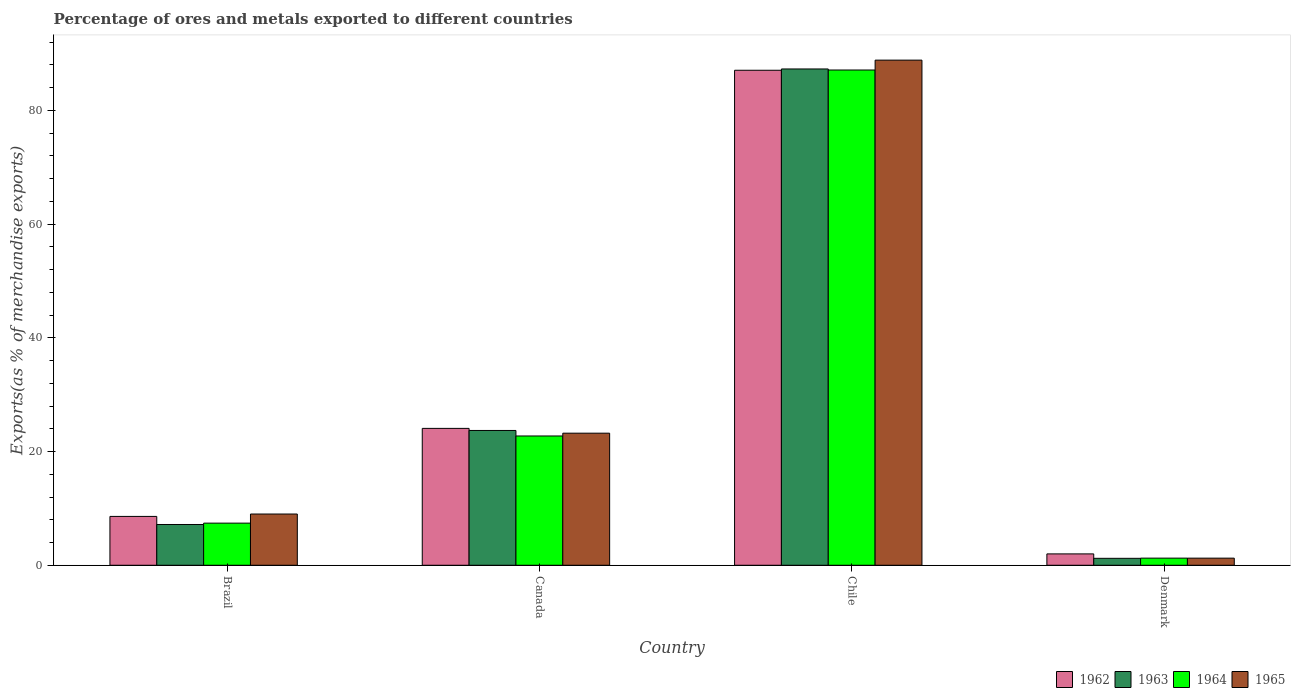Are the number of bars per tick equal to the number of legend labels?
Your answer should be very brief. Yes. Are the number of bars on each tick of the X-axis equal?
Provide a short and direct response. Yes. How many bars are there on the 2nd tick from the left?
Offer a very short reply. 4. What is the percentage of exports to different countries in 1962 in Denmark?
Your answer should be compact. 2. Across all countries, what is the maximum percentage of exports to different countries in 1963?
Your response must be concise. 87.28. Across all countries, what is the minimum percentage of exports to different countries in 1963?
Make the answer very short. 1.22. In which country was the percentage of exports to different countries in 1962 maximum?
Give a very brief answer. Chile. In which country was the percentage of exports to different countries in 1963 minimum?
Offer a terse response. Denmark. What is the total percentage of exports to different countries in 1963 in the graph?
Your answer should be compact. 119.38. What is the difference between the percentage of exports to different countries in 1965 in Canada and that in Chile?
Provide a short and direct response. -65.61. What is the difference between the percentage of exports to different countries in 1962 in Chile and the percentage of exports to different countries in 1964 in Canada?
Your answer should be very brief. 64.32. What is the average percentage of exports to different countries in 1965 per country?
Your answer should be compact. 30.58. What is the difference between the percentage of exports to different countries of/in 1963 and percentage of exports to different countries of/in 1965 in Denmark?
Offer a terse response. -0.03. In how many countries, is the percentage of exports to different countries in 1963 greater than 56 %?
Offer a very short reply. 1. What is the ratio of the percentage of exports to different countries in 1965 in Brazil to that in Canada?
Offer a very short reply. 0.39. Is the difference between the percentage of exports to different countries in 1963 in Canada and Chile greater than the difference between the percentage of exports to different countries in 1965 in Canada and Chile?
Provide a short and direct response. Yes. What is the difference between the highest and the second highest percentage of exports to different countries in 1963?
Offer a terse response. -16.54. What is the difference between the highest and the lowest percentage of exports to different countries in 1963?
Give a very brief answer. 86.06. In how many countries, is the percentage of exports to different countries in 1965 greater than the average percentage of exports to different countries in 1965 taken over all countries?
Your answer should be very brief. 1. Is it the case that in every country, the sum of the percentage of exports to different countries in 1963 and percentage of exports to different countries in 1964 is greater than the sum of percentage of exports to different countries in 1962 and percentage of exports to different countries in 1965?
Make the answer very short. No. What does the 1st bar from the right in Canada represents?
Keep it short and to the point. 1965. Is it the case that in every country, the sum of the percentage of exports to different countries in 1964 and percentage of exports to different countries in 1962 is greater than the percentage of exports to different countries in 1965?
Provide a short and direct response. Yes. Are all the bars in the graph horizontal?
Offer a terse response. No. How many countries are there in the graph?
Make the answer very short. 4. Are the values on the major ticks of Y-axis written in scientific E-notation?
Provide a short and direct response. No. Does the graph contain any zero values?
Ensure brevity in your answer.  No. Where does the legend appear in the graph?
Your answer should be very brief. Bottom right. What is the title of the graph?
Your answer should be very brief. Percentage of ores and metals exported to different countries. Does "1960" appear as one of the legend labels in the graph?
Your response must be concise. No. What is the label or title of the X-axis?
Your answer should be very brief. Country. What is the label or title of the Y-axis?
Provide a short and direct response. Exports(as % of merchandise exports). What is the Exports(as % of merchandise exports) in 1962 in Brazil?
Provide a succinct answer. 8.59. What is the Exports(as % of merchandise exports) of 1963 in Brazil?
Provide a succinct answer. 7.17. What is the Exports(as % of merchandise exports) of 1964 in Brazil?
Ensure brevity in your answer.  7.41. What is the Exports(as % of merchandise exports) of 1965 in Brazil?
Offer a very short reply. 9.01. What is the Exports(as % of merchandise exports) of 1962 in Canada?
Ensure brevity in your answer.  24.07. What is the Exports(as % of merchandise exports) in 1963 in Canada?
Provide a succinct answer. 23.71. What is the Exports(as % of merchandise exports) of 1964 in Canada?
Offer a very short reply. 22.74. What is the Exports(as % of merchandise exports) of 1965 in Canada?
Your answer should be compact. 23.23. What is the Exports(as % of merchandise exports) in 1962 in Chile?
Provide a short and direct response. 87.06. What is the Exports(as % of merchandise exports) in 1963 in Chile?
Provide a short and direct response. 87.28. What is the Exports(as % of merchandise exports) in 1964 in Chile?
Provide a short and direct response. 87.1. What is the Exports(as % of merchandise exports) of 1965 in Chile?
Provide a succinct answer. 88.84. What is the Exports(as % of merchandise exports) of 1962 in Denmark?
Keep it short and to the point. 2. What is the Exports(as % of merchandise exports) of 1963 in Denmark?
Provide a succinct answer. 1.22. What is the Exports(as % of merchandise exports) of 1964 in Denmark?
Keep it short and to the point. 1.25. What is the Exports(as % of merchandise exports) of 1965 in Denmark?
Provide a short and direct response. 1.25. Across all countries, what is the maximum Exports(as % of merchandise exports) of 1962?
Provide a short and direct response. 87.06. Across all countries, what is the maximum Exports(as % of merchandise exports) of 1963?
Ensure brevity in your answer.  87.28. Across all countries, what is the maximum Exports(as % of merchandise exports) of 1964?
Offer a very short reply. 87.1. Across all countries, what is the maximum Exports(as % of merchandise exports) in 1965?
Your response must be concise. 88.84. Across all countries, what is the minimum Exports(as % of merchandise exports) in 1962?
Give a very brief answer. 2. Across all countries, what is the minimum Exports(as % of merchandise exports) in 1963?
Your answer should be very brief. 1.22. Across all countries, what is the minimum Exports(as % of merchandise exports) in 1964?
Your answer should be compact. 1.25. Across all countries, what is the minimum Exports(as % of merchandise exports) of 1965?
Offer a terse response. 1.25. What is the total Exports(as % of merchandise exports) in 1962 in the graph?
Provide a succinct answer. 121.72. What is the total Exports(as % of merchandise exports) of 1963 in the graph?
Your answer should be compact. 119.38. What is the total Exports(as % of merchandise exports) in 1964 in the graph?
Make the answer very short. 118.5. What is the total Exports(as % of merchandise exports) of 1965 in the graph?
Provide a succinct answer. 122.32. What is the difference between the Exports(as % of merchandise exports) of 1962 in Brazil and that in Canada?
Ensure brevity in your answer.  -15.48. What is the difference between the Exports(as % of merchandise exports) of 1963 in Brazil and that in Canada?
Your answer should be compact. -16.54. What is the difference between the Exports(as % of merchandise exports) in 1964 in Brazil and that in Canada?
Provide a succinct answer. -15.33. What is the difference between the Exports(as % of merchandise exports) of 1965 in Brazil and that in Canada?
Give a very brief answer. -14.22. What is the difference between the Exports(as % of merchandise exports) in 1962 in Brazil and that in Chile?
Provide a short and direct response. -78.46. What is the difference between the Exports(as % of merchandise exports) of 1963 in Brazil and that in Chile?
Make the answer very short. -80.11. What is the difference between the Exports(as % of merchandise exports) of 1964 in Brazil and that in Chile?
Provide a succinct answer. -79.69. What is the difference between the Exports(as % of merchandise exports) in 1965 in Brazil and that in Chile?
Give a very brief answer. -79.83. What is the difference between the Exports(as % of merchandise exports) in 1962 in Brazil and that in Denmark?
Keep it short and to the point. 6.59. What is the difference between the Exports(as % of merchandise exports) in 1963 in Brazil and that in Denmark?
Offer a terse response. 5.95. What is the difference between the Exports(as % of merchandise exports) of 1964 in Brazil and that in Denmark?
Provide a succinct answer. 6.15. What is the difference between the Exports(as % of merchandise exports) of 1965 in Brazil and that in Denmark?
Keep it short and to the point. 7.76. What is the difference between the Exports(as % of merchandise exports) in 1962 in Canada and that in Chile?
Offer a terse response. -62.98. What is the difference between the Exports(as % of merchandise exports) of 1963 in Canada and that in Chile?
Provide a short and direct response. -63.58. What is the difference between the Exports(as % of merchandise exports) of 1964 in Canada and that in Chile?
Ensure brevity in your answer.  -64.36. What is the difference between the Exports(as % of merchandise exports) of 1965 in Canada and that in Chile?
Provide a succinct answer. -65.61. What is the difference between the Exports(as % of merchandise exports) in 1962 in Canada and that in Denmark?
Give a very brief answer. 22.07. What is the difference between the Exports(as % of merchandise exports) in 1963 in Canada and that in Denmark?
Provide a short and direct response. 22.49. What is the difference between the Exports(as % of merchandise exports) of 1964 in Canada and that in Denmark?
Your answer should be very brief. 21.48. What is the difference between the Exports(as % of merchandise exports) in 1965 in Canada and that in Denmark?
Keep it short and to the point. 21.98. What is the difference between the Exports(as % of merchandise exports) of 1962 in Chile and that in Denmark?
Your answer should be compact. 85.06. What is the difference between the Exports(as % of merchandise exports) of 1963 in Chile and that in Denmark?
Your answer should be compact. 86.06. What is the difference between the Exports(as % of merchandise exports) in 1964 in Chile and that in Denmark?
Provide a short and direct response. 85.84. What is the difference between the Exports(as % of merchandise exports) of 1965 in Chile and that in Denmark?
Your response must be concise. 87.58. What is the difference between the Exports(as % of merchandise exports) of 1962 in Brazil and the Exports(as % of merchandise exports) of 1963 in Canada?
Keep it short and to the point. -15.11. What is the difference between the Exports(as % of merchandise exports) in 1962 in Brazil and the Exports(as % of merchandise exports) in 1964 in Canada?
Keep it short and to the point. -14.15. What is the difference between the Exports(as % of merchandise exports) of 1962 in Brazil and the Exports(as % of merchandise exports) of 1965 in Canada?
Your response must be concise. -14.64. What is the difference between the Exports(as % of merchandise exports) in 1963 in Brazil and the Exports(as % of merchandise exports) in 1964 in Canada?
Offer a very short reply. -15.57. What is the difference between the Exports(as % of merchandise exports) of 1963 in Brazil and the Exports(as % of merchandise exports) of 1965 in Canada?
Your answer should be compact. -16.06. What is the difference between the Exports(as % of merchandise exports) in 1964 in Brazil and the Exports(as % of merchandise exports) in 1965 in Canada?
Offer a very short reply. -15.82. What is the difference between the Exports(as % of merchandise exports) in 1962 in Brazil and the Exports(as % of merchandise exports) in 1963 in Chile?
Give a very brief answer. -78.69. What is the difference between the Exports(as % of merchandise exports) of 1962 in Brazil and the Exports(as % of merchandise exports) of 1964 in Chile?
Keep it short and to the point. -78.51. What is the difference between the Exports(as % of merchandise exports) in 1962 in Brazil and the Exports(as % of merchandise exports) in 1965 in Chile?
Offer a very short reply. -80.24. What is the difference between the Exports(as % of merchandise exports) in 1963 in Brazil and the Exports(as % of merchandise exports) in 1964 in Chile?
Ensure brevity in your answer.  -79.93. What is the difference between the Exports(as % of merchandise exports) of 1963 in Brazil and the Exports(as % of merchandise exports) of 1965 in Chile?
Your response must be concise. -81.67. What is the difference between the Exports(as % of merchandise exports) in 1964 in Brazil and the Exports(as % of merchandise exports) in 1965 in Chile?
Make the answer very short. -81.43. What is the difference between the Exports(as % of merchandise exports) in 1962 in Brazil and the Exports(as % of merchandise exports) in 1963 in Denmark?
Give a very brief answer. 7.37. What is the difference between the Exports(as % of merchandise exports) of 1962 in Brazil and the Exports(as % of merchandise exports) of 1964 in Denmark?
Give a very brief answer. 7.34. What is the difference between the Exports(as % of merchandise exports) in 1962 in Brazil and the Exports(as % of merchandise exports) in 1965 in Denmark?
Offer a terse response. 7.34. What is the difference between the Exports(as % of merchandise exports) of 1963 in Brazil and the Exports(as % of merchandise exports) of 1964 in Denmark?
Your answer should be compact. 5.92. What is the difference between the Exports(as % of merchandise exports) of 1963 in Brazil and the Exports(as % of merchandise exports) of 1965 in Denmark?
Provide a short and direct response. 5.92. What is the difference between the Exports(as % of merchandise exports) of 1964 in Brazil and the Exports(as % of merchandise exports) of 1965 in Denmark?
Offer a very short reply. 6.16. What is the difference between the Exports(as % of merchandise exports) in 1962 in Canada and the Exports(as % of merchandise exports) in 1963 in Chile?
Ensure brevity in your answer.  -63.21. What is the difference between the Exports(as % of merchandise exports) in 1962 in Canada and the Exports(as % of merchandise exports) in 1964 in Chile?
Your response must be concise. -63.03. What is the difference between the Exports(as % of merchandise exports) of 1962 in Canada and the Exports(as % of merchandise exports) of 1965 in Chile?
Your answer should be very brief. -64.76. What is the difference between the Exports(as % of merchandise exports) in 1963 in Canada and the Exports(as % of merchandise exports) in 1964 in Chile?
Offer a very short reply. -63.39. What is the difference between the Exports(as % of merchandise exports) in 1963 in Canada and the Exports(as % of merchandise exports) in 1965 in Chile?
Provide a short and direct response. -65.13. What is the difference between the Exports(as % of merchandise exports) in 1964 in Canada and the Exports(as % of merchandise exports) in 1965 in Chile?
Your response must be concise. -66.1. What is the difference between the Exports(as % of merchandise exports) of 1962 in Canada and the Exports(as % of merchandise exports) of 1963 in Denmark?
Keep it short and to the point. 22.85. What is the difference between the Exports(as % of merchandise exports) of 1962 in Canada and the Exports(as % of merchandise exports) of 1964 in Denmark?
Give a very brief answer. 22.82. What is the difference between the Exports(as % of merchandise exports) of 1962 in Canada and the Exports(as % of merchandise exports) of 1965 in Denmark?
Offer a terse response. 22.82. What is the difference between the Exports(as % of merchandise exports) in 1963 in Canada and the Exports(as % of merchandise exports) in 1964 in Denmark?
Make the answer very short. 22.45. What is the difference between the Exports(as % of merchandise exports) of 1963 in Canada and the Exports(as % of merchandise exports) of 1965 in Denmark?
Offer a very short reply. 22.45. What is the difference between the Exports(as % of merchandise exports) in 1964 in Canada and the Exports(as % of merchandise exports) in 1965 in Denmark?
Keep it short and to the point. 21.49. What is the difference between the Exports(as % of merchandise exports) in 1962 in Chile and the Exports(as % of merchandise exports) in 1963 in Denmark?
Keep it short and to the point. 85.84. What is the difference between the Exports(as % of merchandise exports) of 1962 in Chile and the Exports(as % of merchandise exports) of 1964 in Denmark?
Keep it short and to the point. 85.8. What is the difference between the Exports(as % of merchandise exports) of 1962 in Chile and the Exports(as % of merchandise exports) of 1965 in Denmark?
Keep it short and to the point. 85.8. What is the difference between the Exports(as % of merchandise exports) of 1963 in Chile and the Exports(as % of merchandise exports) of 1964 in Denmark?
Your answer should be compact. 86.03. What is the difference between the Exports(as % of merchandise exports) in 1963 in Chile and the Exports(as % of merchandise exports) in 1965 in Denmark?
Ensure brevity in your answer.  86.03. What is the difference between the Exports(as % of merchandise exports) of 1964 in Chile and the Exports(as % of merchandise exports) of 1965 in Denmark?
Your answer should be very brief. 85.85. What is the average Exports(as % of merchandise exports) in 1962 per country?
Provide a succinct answer. 30.43. What is the average Exports(as % of merchandise exports) in 1963 per country?
Offer a very short reply. 29.84. What is the average Exports(as % of merchandise exports) of 1964 per country?
Your answer should be very brief. 29.62. What is the average Exports(as % of merchandise exports) in 1965 per country?
Your answer should be very brief. 30.58. What is the difference between the Exports(as % of merchandise exports) of 1962 and Exports(as % of merchandise exports) of 1963 in Brazil?
Offer a terse response. 1.42. What is the difference between the Exports(as % of merchandise exports) in 1962 and Exports(as % of merchandise exports) in 1964 in Brazil?
Provide a short and direct response. 1.18. What is the difference between the Exports(as % of merchandise exports) in 1962 and Exports(as % of merchandise exports) in 1965 in Brazil?
Your answer should be compact. -0.42. What is the difference between the Exports(as % of merchandise exports) of 1963 and Exports(as % of merchandise exports) of 1964 in Brazil?
Your response must be concise. -0.24. What is the difference between the Exports(as % of merchandise exports) in 1963 and Exports(as % of merchandise exports) in 1965 in Brazil?
Keep it short and to the point. -1.84. What is the difference between the Exports(as % of merchandise exports) of 1964 and Exports(as % of merchandise exports) of 1965 in Brazil?
Your answer should be compact. -1.6. What is the difference between the Exports(as % of merchandise exports) in 1962 and Exports(as % of merchandise exports) in 1963 in Canada?
Offer a very short reply. 0.37. What is the difference between the Exports(as % of merchandise exports) of 1962 and Exports(as % of merchandise exports) of 1964 in Canada?
Provide a succinct answer. 1.33. What is the difference between the Exports(as % of merchandise exports) in 1962 and Exports(as % of merchandise exports) in 1965 in Canada?
Give a very brief answer. 0.84. What is the difference between the Exports(as % of merchandise exports) of 1963 and Exports(as % of merchandise exports) of 1964 in Canada?
Offer a very short reply. 0.97. What is the difference between the Exports(as % of merchandise exports) in 1963 and Exports(as % of merchandise exports) in 1965 in Canada?
Ensure brevity in your answer.  0.48. What is the difference between the Exports(as % of merchandise exports) of 1964 and Exports(as % of merchandise exports) of 1965 in Canada?
Your answer should be compact. -0.49. What is the difference between the Exports(as % of merchandise exports) in 1962 and Exports(as % of merchandise exports) in 1963 in Chile?
Give a very brief answer. -0.23. What is the difference between the Exports(as % of merchandise exports) in 1962 and Exports(as % of merchandise exports) in 1964 in Chile?
Your response must be concise. -0.04. What is the difference between the Exports(as % of merchandise exports) in 1962 and Exports(as % of merchandise exports) in 1965 in Chile?
Your answer should be compact. -1.78. What is the difference between the Exports(as % of merchandise exports) in 1963 and Exports(as % of merchandise exports) in 1964 in Chile?
Ensure brevity in your answer.  0.18. What is the difference between the Exports(as % of merchandise exports) of 1963 and Exports(as % of merchandise exports) of 1965 in Chile?
Your answer should be compact. -1.55. What is the difference between the Exports(as % of merchandise exports) of 1964 and Exports(as % of merchandise exports) of 1965 in Chile?
Provide a succinct answer. -1.74. What is the difference between the Exports(as % of merchandise exports) of 1962 and Exports(as % of merchandise exports) of 1963 in Denmark?
Ensure brevity in your answer.  0.78. What is the difference between the Exports(as % of merchandise exports) in 1962 and Exports(as % of merchandise exports) in 1964 in Denmark?
Your response must be concise. 0.74. What is the difference between the Exports(as % of merchandise exports) in 1962 and Exports(as % of merchandise exports) in 1965 in Denmark?
Keep it short and to the point. 0.75. What is the difference between the Exports(as % of merchandise exports) in 1963 and Exports(as % of merchandise exports) in 1964 in Denmark?
Offer a terse response. -0.03. What is the difference between the Exports(as % of merchandise exports) of 1963 and Exports(as % of merchandise exports) of 1965 in Denmark?
Provide a short and direct response. -0.03. What is the difference between the Exports(as % of merchandise exports) in 1964 and Exports(as % of merchandise exports) in 1965 in Denmark?
Offer a terse response. 0. What is the ratio of the Exports(as % of merchandise exports) of 1962 in Brazil to that in Canada?
Make the answer very short. 0.36. What is the ratio of the Exports(as % of merchandise exports) of 1963 in Brazil to that in Canada?
Offer a very short reply. 0.3. What is the ratio of the Exports(as % of merchandise exports) in 1964 in Brazil to that in Canada?
Give a very brief answer. 0.33. What is the ratio of the Exports(as % of merchandise exports) of 1965 in Brazil to that in Canada?
Ensure brevity in your answer.  0.39. What is the ratio of the Exports(as % of merchandise exports) in 1962 in Brazil to that in Chile?
Your answer should be very brief. 0.1. What is the ratio of the Exports(as % of merchandise exports) of 1963 in Brazil to that in Chile?
Ensure brevity in your answer.  0.08. What is the ratio of the Exports(as % of merchandise exports) in 1964 in Brazil to that in Chile?
Your response must be concise. 0.09. What is the ratio of the Exports(as % of merchandise exports) of 1965 in Brazil to that in Chile?
Give a very brief answer. 0.1. What is the ratio of the Exports(as % of merchandise exports) of 1962 in Brazil to that in Denmark?
Your answer should be compact. 4.3. What is the ratio of the Exports(as % of merchandise exports) of 1963 in Brazil to that in Denmark?
Give a very brief answer. 5.88. What is the ratio of the Exports(as % of merchandise exports) of 1964 in Brazil to that in Denmark?
Keep it short and to the point. 5.91. What is the ratio of the Exports(as % of merchandise exports) of 1965 in Brazil to that in Denmark?
Keep it short and to the point. 7.2. What is the ratio of the Exports(as % of merchandise exports) of 1962 in Canada to that in Chile?
Ensure brevity in your answer.  0.28. What is the ratio of the Exports(as % of merchandise exports) in 1963 in Canada to that in Chile?
Provide a short and direct response. 0.27. What is the ratio of the Exports(as % of merchandise exports) of 1964 in Canada to that in Chile?
Offer a terse response. 0.26. What is the ratio of the Exports(as % of merchandise exports) in 1965 in Canada to that in Chile?
Make the answer very short. 0.26. What is the ratio of the Exports(as % of merchandise exports) in 1962 in Canada to that in Denmark?
Ensure brevity in your answer.  12.05. What is the ratio of the Exports(as % of merchandise exports) in 1963 in Canada to that in Denmark?
Your answer should be compact. 19.44. What is the ratio of the Exports(as % of merchandise exports) in 1964 in Canada to that in Denmark?
Keep it short and to the point. 18.13. What is the ratio of the Exports(as % of merchandise exports) in 1965 in Canada to that in Denmark?
Offer a terse response. 18.56. What is the ratio of the Exports(as % of merchandise exports) in 1962 in Chile to that in Denmark?
Your response must be concise. 43.58. What is the ratio of the Exports(as % of merchandise exports) of 1963 in Chile to that in Denmark?
Provide a succinct answer. 71.57. What is the ratio of the Exports(as % of merchandise exports) in 1964 in Chile to that in Denmark?
Ensure brevity in your answer.  69.44. What is the ratio of the Exports(as % of merchandise exports) in 1965 in Chile to that in Denmark?
Ensure brevity in your answer.  71. What is the difference between the highest and the second highest Exports(as % of merchandise exports) of 1962?
Provide a short and direct response. 62.98. What is the difference between the highest and the second highest Exports(as % of merchandise exports) of 1963?
Offer a very short reply. 63.58. What is the difference between the highest and the second highest Exports(as % of merchandise exports) of 1964?
Your answer should be compact. 64.36. What is the difference between the highest and the second highest Exports(as % of merchandise exports) in 1965?
Provide a succinct answer. 65.61. What is the difference between the highest and the lowest Exports(as % of merchandise exports) of 1962?
Provide a succinct answer. 85.06. What is the difference between the highest and the lowest Exports(as % of merchandise exports) in 1963?
Your response must be concise. 86.06. What is the difference between the highest and the lowest Exports(as % of merchandise exports) in 1964?
Provide a short and direct response. 85.84. What is the difference between the highest and the lowest Exports(as % of merchandise exports) in 1965?
Keep it short and to the point. 87.58. 